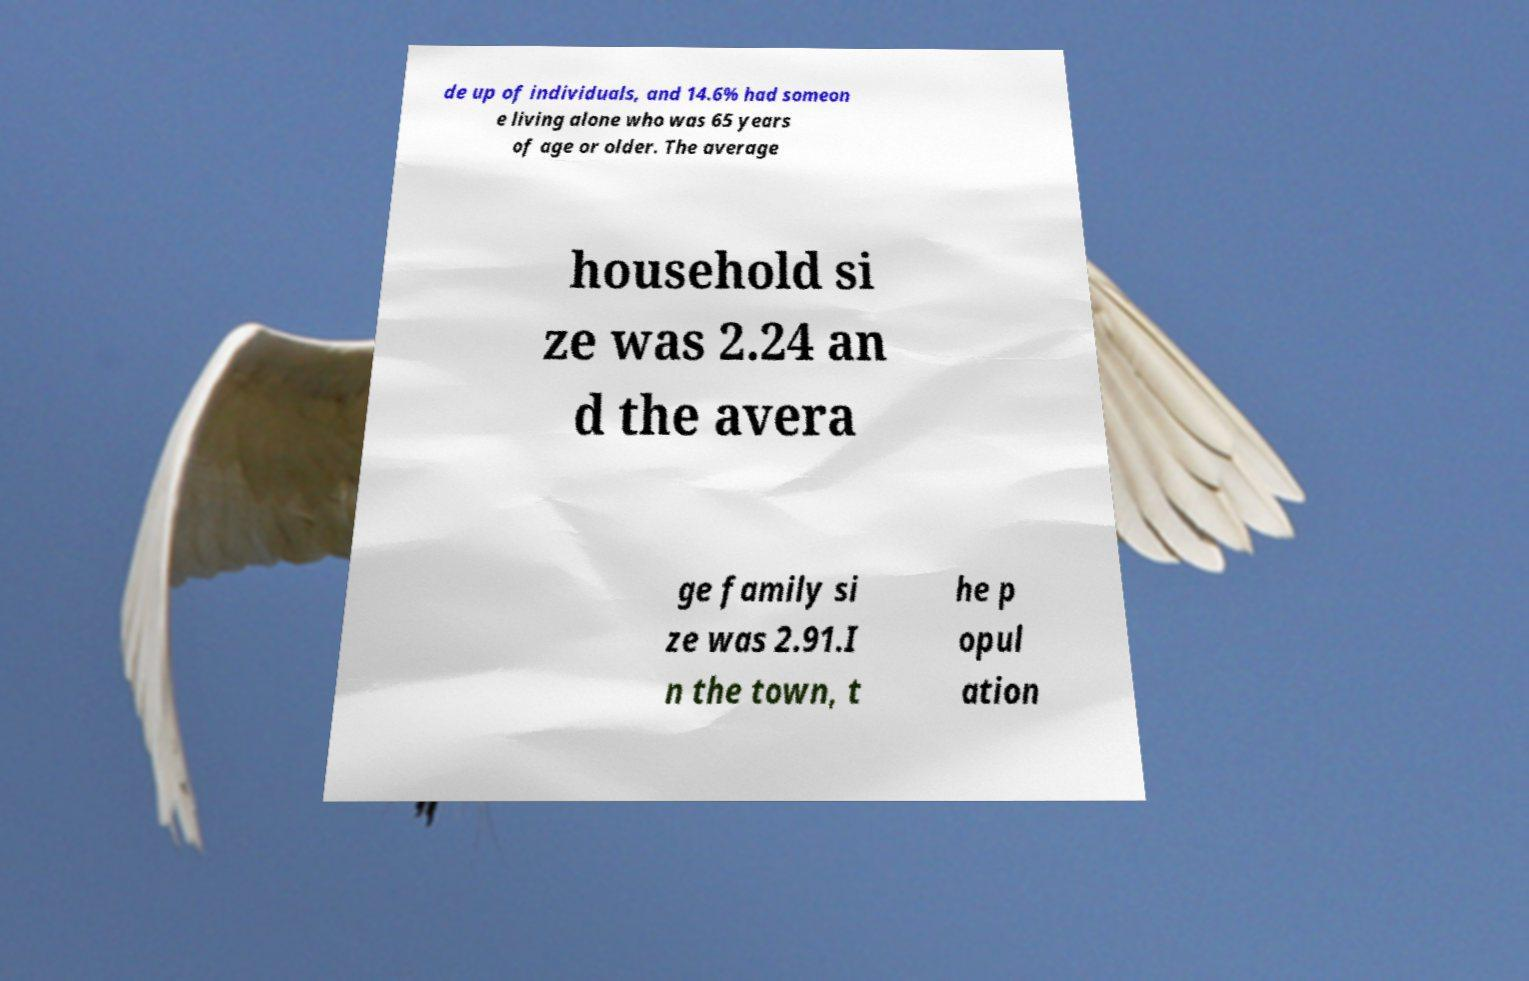I need the written content from this picture converted into text. Can you do that? de up of individuals, and 14.6% had someon e living alone who was 65 years of age or older. The average household si ze was 2.24 an d the avera ge family si ze was 2.91.I n the town, t he p opul ation 